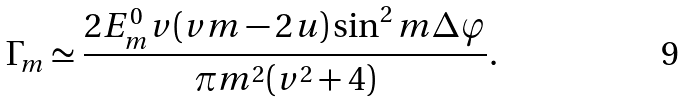<formula> <loc_0><loc_0><loc_500><loc_500>\Gamma _ { m } \simeq \frac { 2 E _ { m } ^ { 0 } v ( v m - 2 u ) \sin ^ { 2 } { m \Delta \varphi } } { \pi m ^ { 2 } ( v ^ { 2 } + 4 ) } .</formula> 